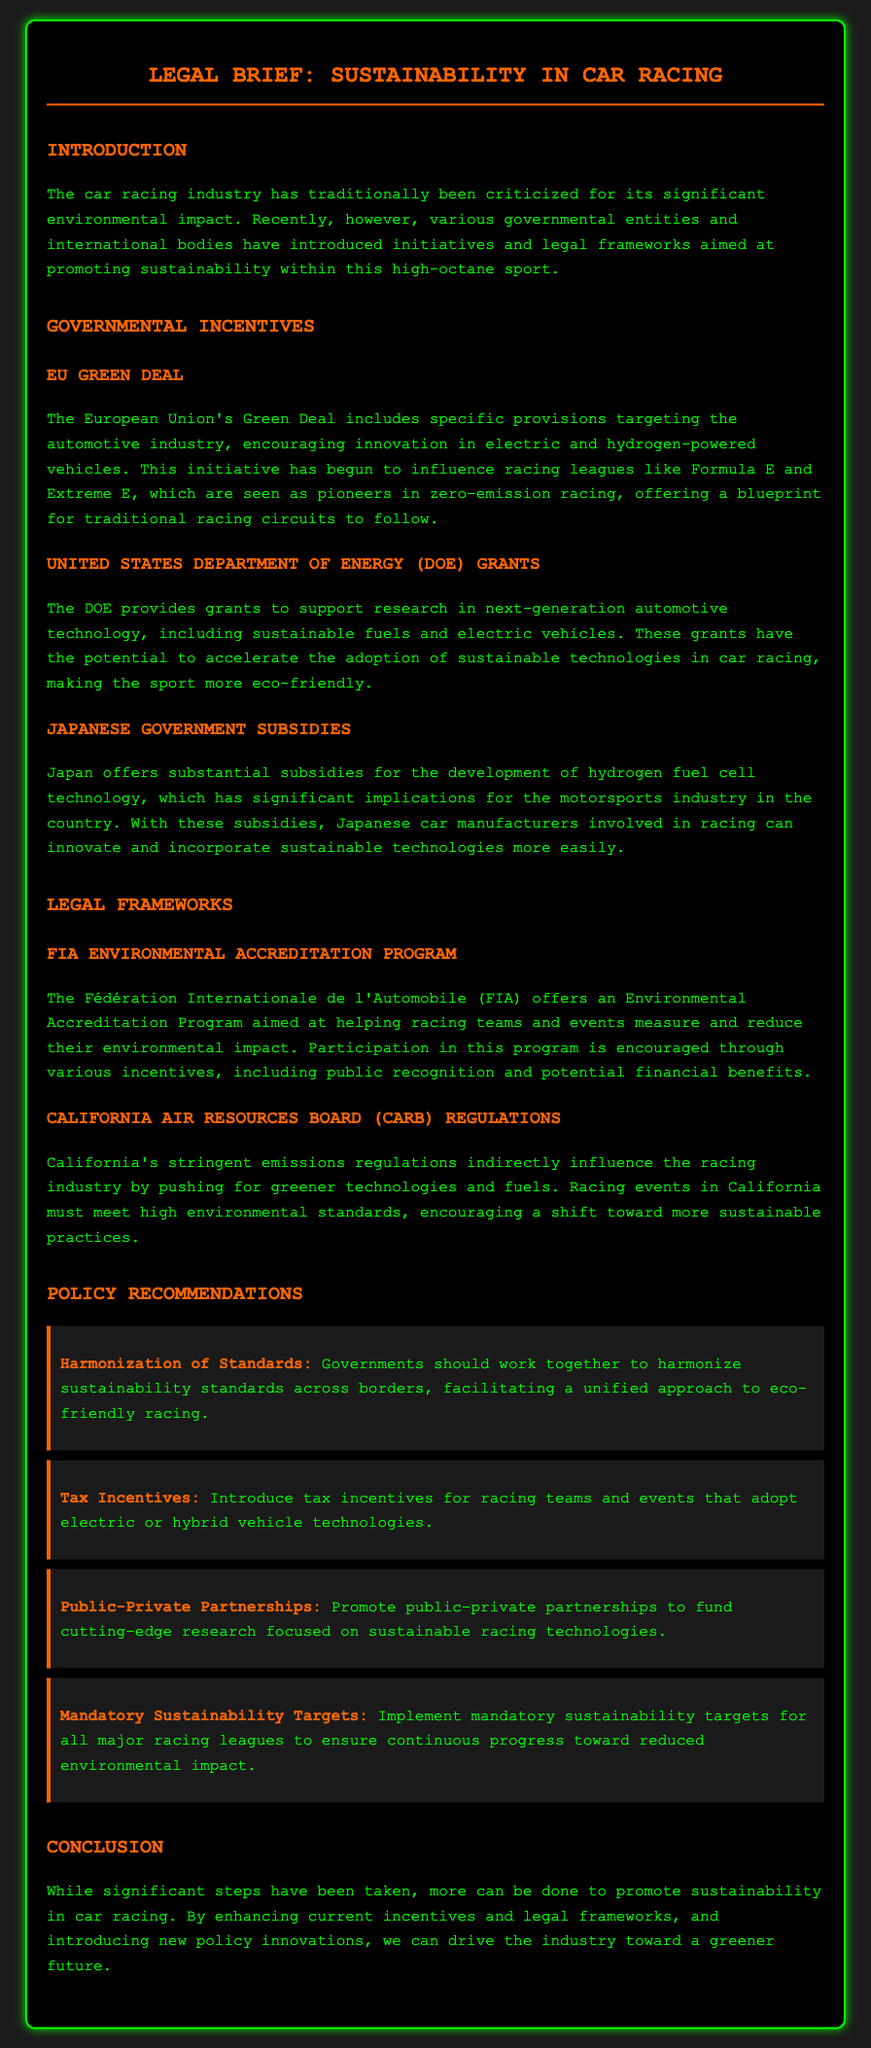What is the title of the document? The title is found in the header of the document, which is "Legal Brief: Sustainability in Car Racing."
Answer: Legal Brief: Sustainability in Car Racing What is one of the initiatives mentioned in the governmental incentives? The initiatives are detailed under governmental incentives; one of them is the "EU Green Deal."
Answer: EU Green Deal Which organization offers an Environmental Accreditation Program? The organization responsible for this program is mentioned in the section on Legal Frameworks.
Answer: FIA What do the tax incentives in the policy recommendations aim to encourage? The document states that tax incentives are intended for teams and events that adopt a specific technology.
Answer: Electric or hybrid vehicle technologies What is the purpose of the DOE grants? The purpose is indicated in the section discussing governmental incentives about supporting research in automotive technology.
Answer: Support research in next-generation automotive technology What is the recommendation for sustainability targets? The recommendation calls for implementation of certain targets within racing leagues.
Answer: Mandatory sustainability targets Which country provides subsidies for hydrogen fuel cell technology? The country providing these subsidies is identified in the section about governmental incentives.
Answer: Japan What type of partnerships does the document suggest promoting? The document outlines a specific type of partnership in the policy recommendations section.
Answer: Public-private partnerships 